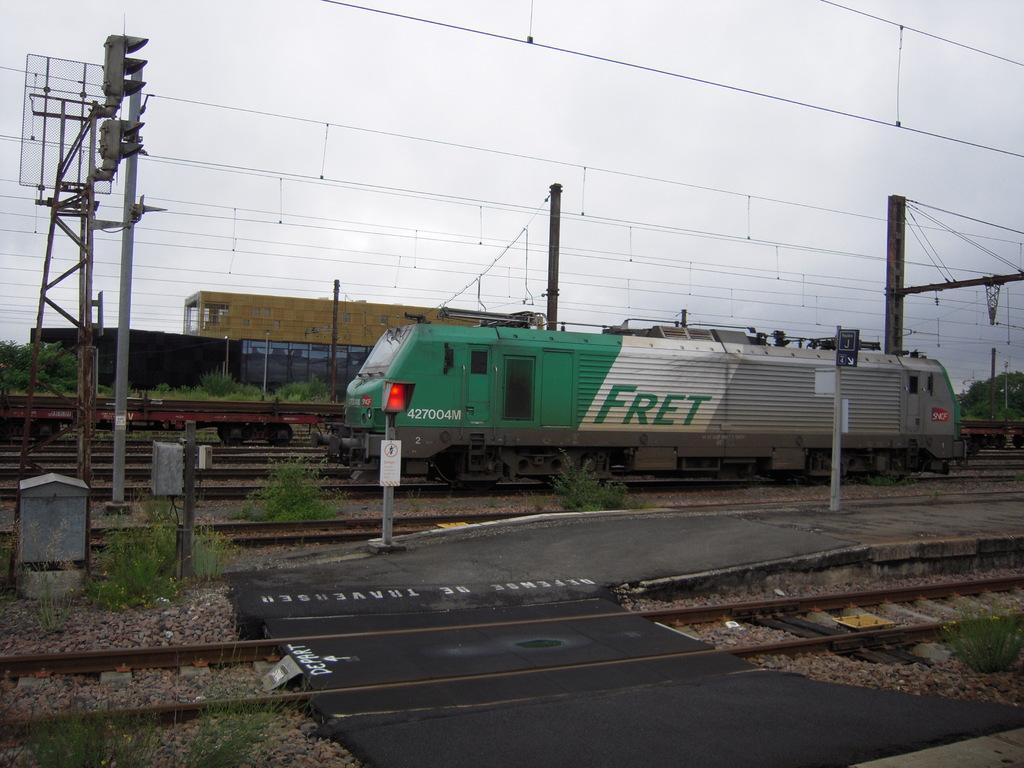<image>
Share a concise interpretation of the image provided. a fret train that is on the tracks in daytime 